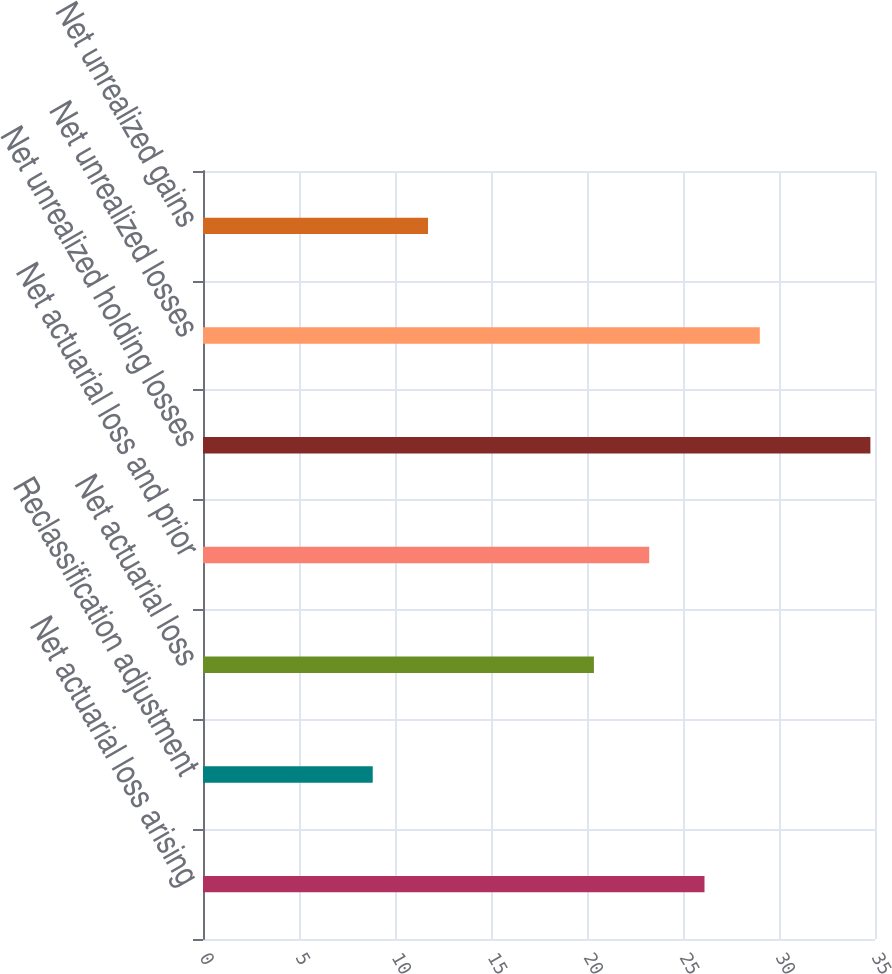<chart> <loc_0><loc_0><loc_500><loc_500><bar_chart><fcel>Net actuarial loss arising<fcel>Reclassification adjustment<fcel>Net actuarial loss<fcel>Net actuarial loss and prior<fcel>Net unrealized holding losses<fcel>Net unrealized losses<fcel>Net unrealized gains<nl><fcel>26.12<fcel>8.84<fcel>20.36<fcel>23.24<fcel>34.76<fcel>29<fcel>11.72<nl></chart> 